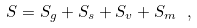Convert formula to latex. <formula><loc_0><loc_0><loc_500><loc_500>S = S _ { g } + S _ { s } + S _ { v } + S _ { m } \ ,</formula> 